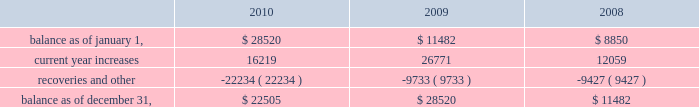American tower corporation and subsidiaries notes to consolidated financial statements recognizing customer revenue , the company must assess the collectability of both the amounts billed and the portion recognized on a straight-line basis .
This assessment takes customer credit risk and business and industry conditions into consideration to ultimately determine the collectability of the amounts billed .
To the extent the amounts , based on management 2019s estimates , may not be collectible , recognition is deferred until such point as the uncertainty is resolved .
Any amounts which were previously recognized as revenue and subsequently determined to be uncollectible are charged to bad debt expense .
Accounts receivable are reported net of allowances for doubtful accounts related to estimated losses resulting from a customer 2019s inability to make required payments and reserves for amounts invoiced whose collectability is not reasonably assured .
These allowances are generally estimated based on payment patterns , days past due and collection history , and incorporate changes in economic conditions that may not be reflected in historical trends , such as customers in bankruptcy , liquidation or reorganization .
Receivables are written-off against the allowances when they are determined uncollectible .
Such determination includes analysis and consideration of the particular conditions of the account .
Changes in the allowances were as follows for the years ended december 31 , ( in thousands ) : .
The company 2019s largest international customer is iusacell , which is the brand name under which a group of companies controlled by grupo iusacell , s.a .
De c.v .
( 201cgrupo iusacell 201d ) operates .
Iusacell represented approximately 4% ( 4 % ) of the company 2019s total revenue for the year ended december 31 , 2010 .
Grupo iusacell has been engaged in a refinancing of a majority of its u.s .
Dollar denominated debt , and in connection with this process , two of the legal entities of the group , including grupo iusacell , voluntarily filed for a pre-packaged concurso mercantil ( a process substantially equivalent to chapter 11 of u.s .
Bankruptcy law ) with the backing of a majority of their financial creditors in december 2010 .
As of december 31 , 2010 , iusacell notes receivable , net , and related assets ( which include financing lease commitments and a deferred rent asset that are primarily long-term in nature ) were $ 19.7 million and $ 51.2 million , respectively .
Functional currency 2014as a result of changes to the organizational structure of the company 2019s subsidiaries in latin america in 2010 , the company determined that effective january 1 , 2010 , the functional currency of its foreign subsidiary in brazil is the brazilian real .
From that point forward , all assets and liabilities held by the subsidiary in brazil are translated into u.s .
Dollars at the exchange rate in effect at the end of the applicable reporting period .
Revenues and expenses are translated at the average monthly exchange rates and the cumulative translation effect is included in stockholders 2019 equity .
The change in functional currency from u.s .
Dollars to brazilian real gave rise to an increase in the net value of certain non-monetary assets and liabilities .
The aggregate impact on such assets and liabilities was $ 39.8 million with an offsetting increase in accumulated other comprehensive income ( loss ) .
As a result of the renegotiation of the company 2019s agreements with its largest international customer , iusacell , which included , among other changes , converting all of iusacell 2019s contractual obligations to the company from u.s .
Dollars to mexican pesos , the company has determined that effective april 1 , 2010 , the functional currency of certain of its foreign subsidiaries in mexico is the mexican peso .
From that point forward , all assets and liabilities held by those subsidiaries in mexico are translated into u.s .
Dollars at the exchange rate in effect at the end of the applicable reporting period .
Revenues and expenses are translated at the average monthly exchange rates and the cumulative translation effect is included in stockholders 2019 equity .
The change in functional .
What is the percentage change in the balance of allowances from 2008 to 2009? 
Computations: ((28520 - 11482) / 11482)
Answer: 1.48389. 